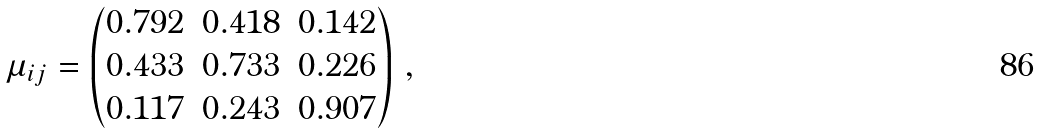Convert formula to latex. <formula><loc_0><loc_0><loc_500><loc_500>\mu _ { i j } = \begin{pmatrix} 0 . 7 9 2 & 0 . 4 1 8 & 0 . 1 4 2 \\ 0 . 4 3 3 & 0 . 7 3 3 & 0 . 2 2 6 \\ 0 . 1 1 7 & 0 . 2 4 3 & 0 . 9 0 7 \end{pmatrix} \, ,</formula> 